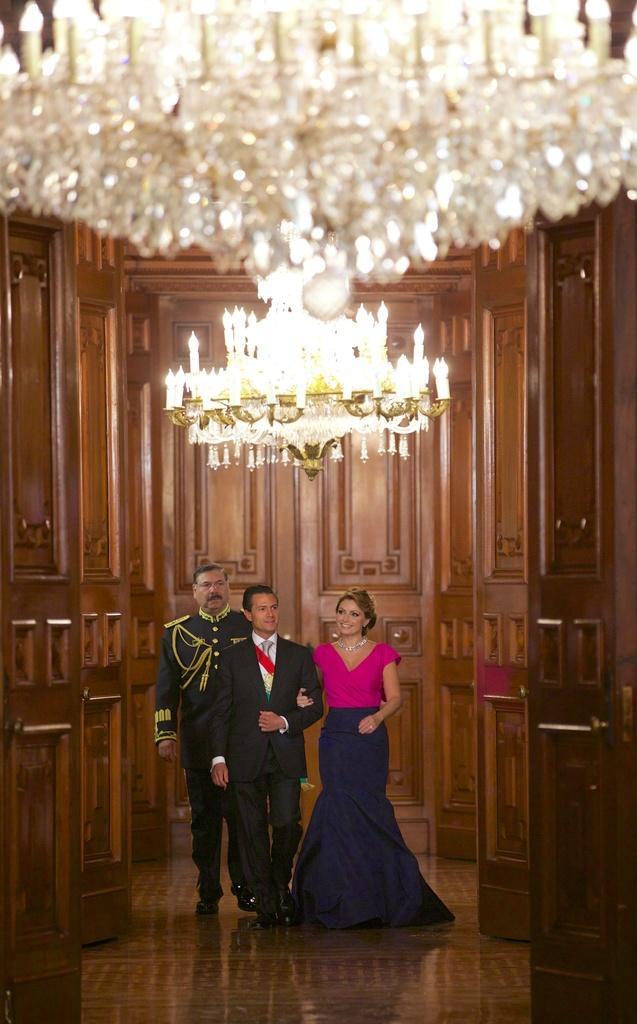Please provide a concise description of this image. In this image, there are three people standing on the floor. On the left and right side of the image, I can see the wooden doors. At the top of the image, there are chandeliers hanging. 